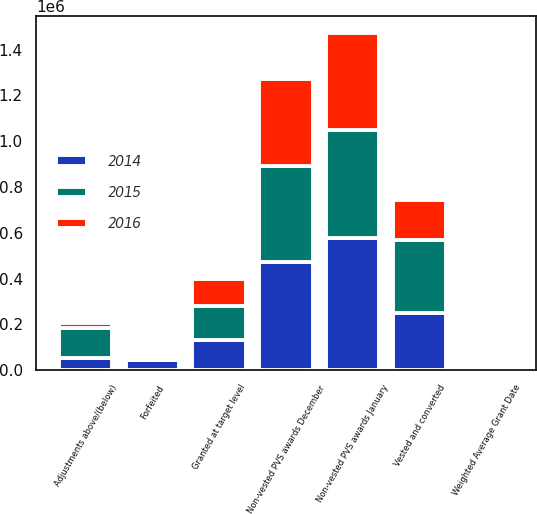<chart> <loc_0><loc_0><loc_500><loc_500><stacked_bar_chart><ecel><fcel>Non-vested PVS awards January<fcel>Granted at target level<fcel>Adjustments above/(below)<fcel>Vested and converted<fcel>Forfeited<fcel>Non-vested PVS awards December<fcel>Weighted Average Grant Date<nl><fcel>2016<fcel>422726<fcel>115035<fcel>19339<fcel>173364<fcel>5674<fcel>378062<fcel>2016<nl><fcel>2015<fcel>470719<fcel>147908<fcel>132444<fcel>318337<fcel>10008<fcel>422726<fcel>2015<nl><fcel>2014<fcel>578358<fcel>133823<fcel>53438<fcel>250205<fcel>44695<fcel>470719<fcel>2014<nl></chart> 